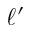<formula> <loc_0><loc_0><loc_500><loc_500>\ell ^ { \prime }</formula> 